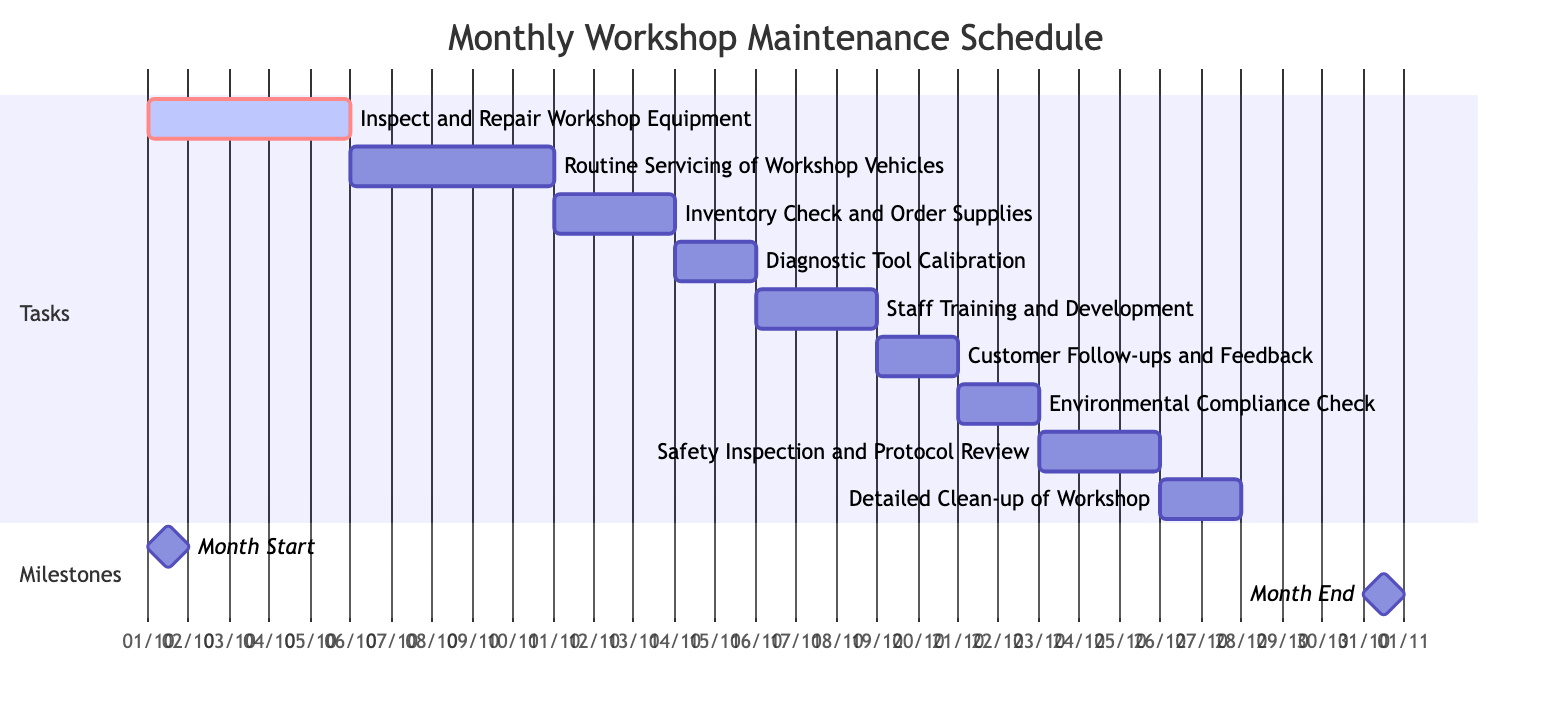What is the first task scheduled in October? The first task listed in the diagram is "Inspect and Repair Workshop Equipment," which starts on October 1.
Answer: Inspect and Repair Workshop Equipment How many tasks are scheduled to be completed in October? There are a total of nine tasks listed for the month of October based on the diagram data.
Answer: 9 What are the dates for the "Safety Inspection and Protocol Review"? The task "Safety Inspection and Protocol Review" starts on October 23 and ends on October 25, as shown in the timeline.
Answer: October 23 to October 25 Which task overlaps with "Customer Follow-ups and Feedback"? The task that overlaps is "Environmental Compliance Check," which starts on October 21, while "Customer Follow-ups and Feedback" ends on October 20.
Answer: Environmental Compliance Check What is the duration of the "Staff Training and Development"? The task "Staff Training and Development" is scheduled for three days, from October 16 to October 18.
Answer: 3 days What is the last task scheduled in October? The last task listed in the diagram is "Detailed Clean-up of Workshop," which ends on October 27.
Answer: Detailed Clean-up of Workshop How many days are there between the "Diagnostic Tool Calibration" and "Staff Training and Development"? The "Diagnostic Tool Calibration" ends on October 15, and "Staff Training and Development" starts on October 16, which means there is one day in between.
Answer: 1 day What is the duration of the "Routine Servicing of Workshop Vehicles"? The task "Routine Servicing of Workshop Vehicles" lasts for five days, beginning on October 6 and concluding on October 10.
Answer: 5 days Which task starts the latest in the October schedule? The task that starts the latest is "Detailed Clean-up of Workshop," which begins on October 26.
Answer: Detailed Clean-up of Workshop 